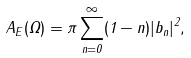<formula> <loc_0><loc_0><loc_500><loc_500>A _ { E } ( \Omega ) = \pi \sum _ { n = 0 } ^ { \infty } ( 1 - n ) | b _ { n } | ^ { 2 } ,</formula> 